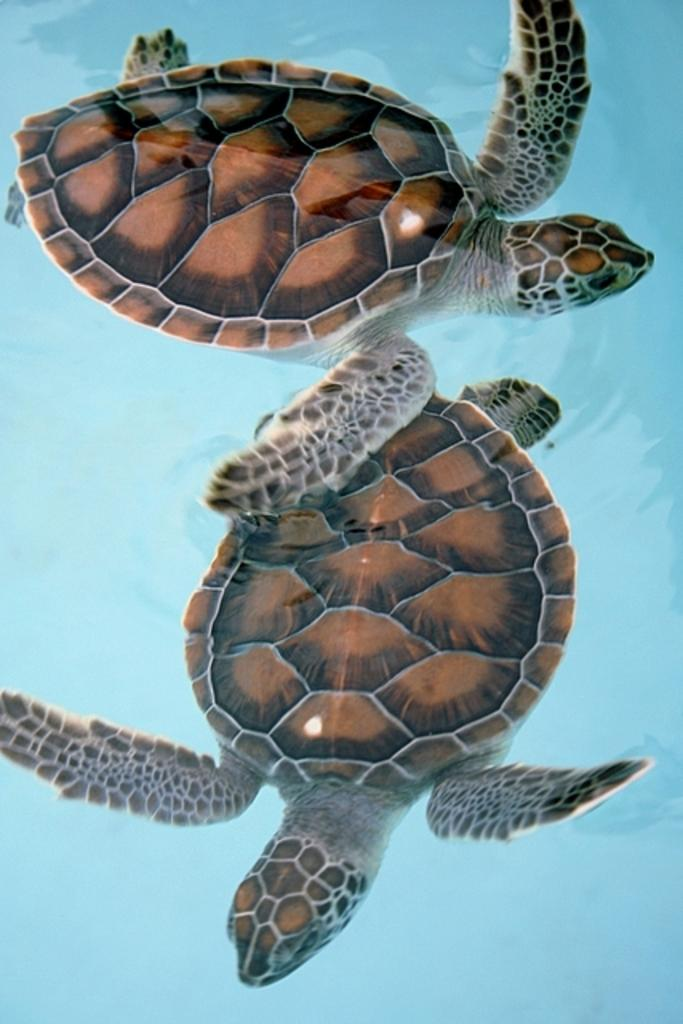What animals can be seen in the image? There are two tortoises in the image. Where are the tortoises located? The tortoises are in the water. What color is the background of the image? The background of the image is blue in color. What type of cabbage is being harvested in the image? There is no cabbage present in the image; it features two tortoises in the water with a blue background. 